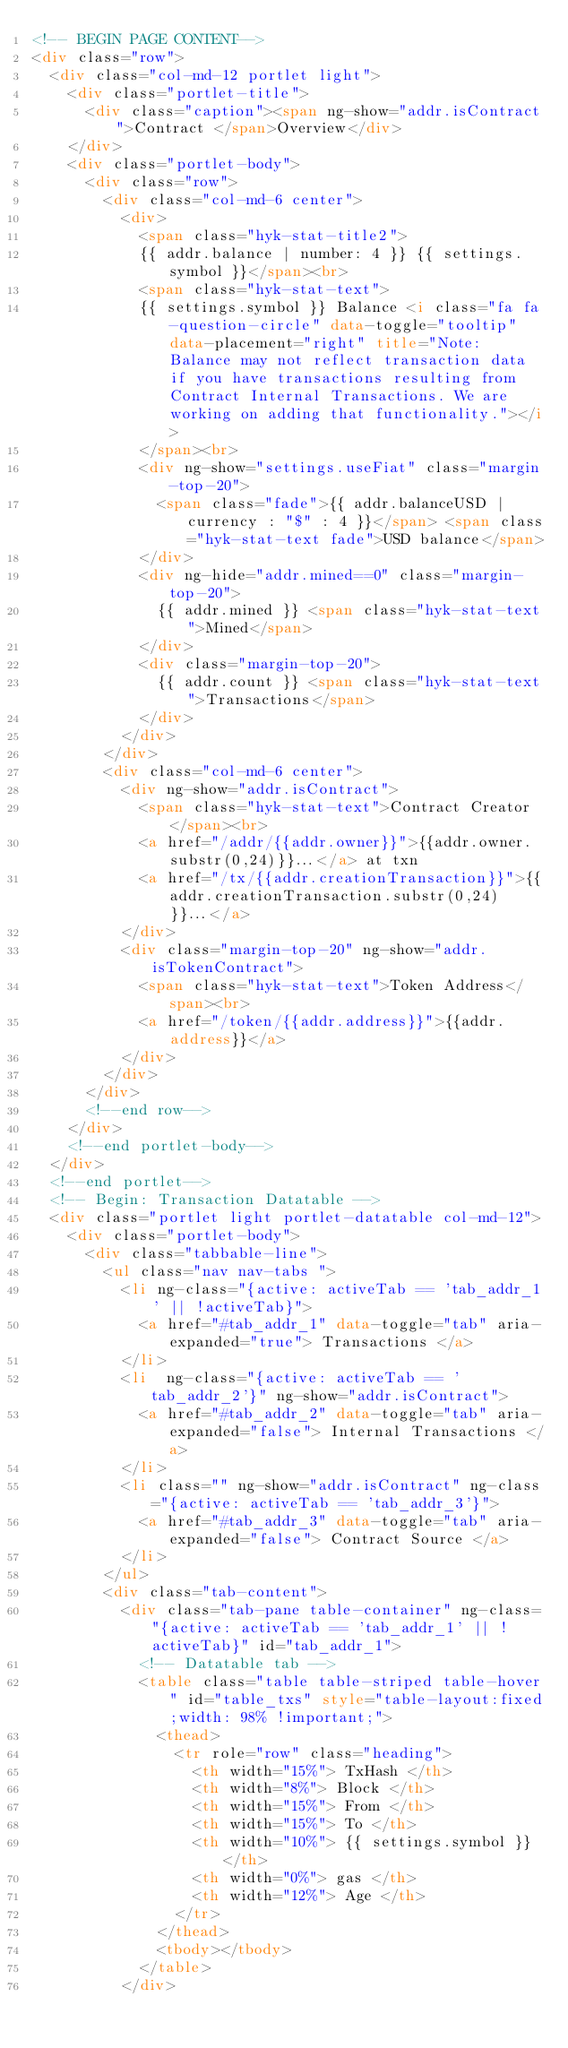Convert code to text. <code><loc_0><loc_0><loc_500><loc_500><_HTML_><!-- BEGIN PAGE CONTENT-->
<div class="row">
  <div class="col-md-12 portlet light">
    <div class="portlet-title">
      <div class="caption"><span ng-show="addr.isContract">Contract </span>Overview</div>
    </div>
    <div class="portlet-body">
      <div class="row">
        <div class="col-md-6 center">
          <div>
            <span class="hyk-stat-title2">
            {{ addr.balance | number: 4 }} {{ settings.symbol }}</span><br>
            <span class="hyk-stat-text">
            {{ settings.symbol }} Balance <i class="fa fa-question-circle" data-toggle="tooltip" data-placement="right" title="Note: Balance may not reflect transaction data if you have transactions resulting from Contract Internal Transactions. We are working on adding that functionality."></i>
            </span><br>
            <div ng-show="settings.useFiat" class="margin-top-20">
              <span class="fade">{{ addr.balanceUSD | currency : "$" : 4 }}</span> <span class="hyk-stat-text fade">USD balance</span>
            </div>
            <div ng-hide="addr.mined==0" class="margin-top-20">
              {{ addr.mined }} <span class="hyk-stat-text">Mined</span>
            </div>
            <div class="margin-top-20">
              {{ addr.count }} <span class="hyk-stat-text">Transactions</span>
            </div>
          </div>
        </div>
        <div class="col-md-6 center">
          <div ng-show="addr.isContract">
            <span class="hyk-stat-text">Contract Creator</span><br>
            <a href="/addr/{{addr.owner}}">{{addr.owner.substr(0,24)}}...</a> at txn
            <a href="/tx/{{addr.creationTransaction}}">{{addr.creationTransaction.substr(0,24)}}...</a>
          </div>
          <div class="margin-top-20" ng-show="addr.isTokenContract">
            <span class="hyk-stat-text">Token Address</span><br>
            <a href="/token/{{addr.address}}">{{addr.address}}</a>
          </div>
        </div>
      </div>
      <!--end row-->
    </div>
    <!--end portlet-body-->
  </div>
  <!--end portlet-->
  <!-- Begin: Transaction Datatable -->
  <div class="portlet light portlet-datatable col-md-12">
    <div class="portlet-body">
      <div class="tabbable-line">
        <ul class="nav nav-tabs ">
          <li ng-class="{active: activeTab == 'tab_addr_1' || !activeTab}">
            <a href="#tab_addr_1" data-toggle="tab" aria-expanded="true"> Transactions </a>
          </li>
          <li  ng-class="{active: activeTab == 'tab_addr_2'}" ng-show="addr.isContract">
            <a href="#tab_addr_2" data-toggle="tab" aria-expanded="false"> Internal Transactions </a>
          </li>
          <li class="" ng-show="addr.isContract" ng-class="{active: activeTab == 'tab_addr_3'}">
            <a href="#tab_addr_3" data-toggle="tab" aria-expanded="false"> Contract Source </a>
          </li>
        </ul>
        <div class="tab-content">
          <div class="tab-pane table-container" ng-class="{active: activeTab == 'tab_addr_1' || !activeTab}" id="tab_addr_1">
            <!-- Datatable tab -->
            <table class="table table-striped table-hover" id="table_txs" style="table-layout:fixed;width: 98% !important;">
              <thead>
                <tr role="row" class="heading">
                  <th width="15%"> TxHash </th>
                  <th width="8%"> Block </th>
                  <th width="15%"> From </th>
                  <th width="15%"> To </th>
                  <th width="10%"> {{ settings.symbol }} </th>
                  <th width="0%"> gas </th>
                  <th width="12%"> Age </th>
                </tr>
              </thead>
              <tbody></tbody>
            </table>
          </div></code> 